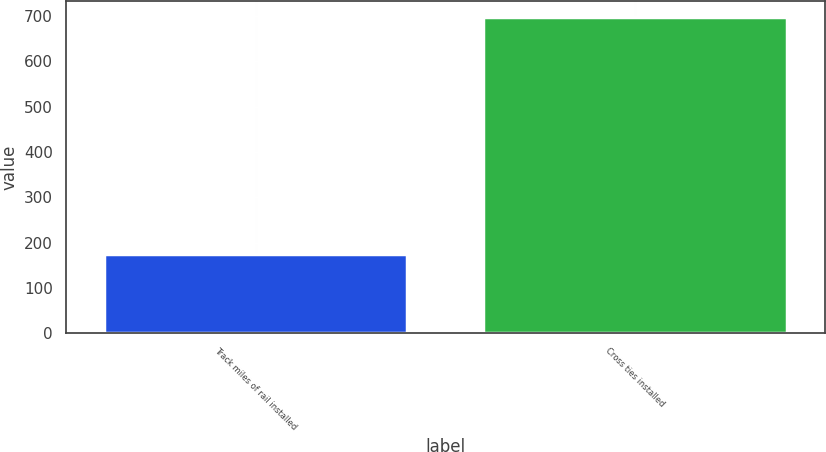<chart> <loc_0><loc_0><loc_500><loc_500><bar_chart><fcel>Track miles of rail installed<fcel>Cross ties installed<nl><fcel>174<fcel>699<nl></chart> 